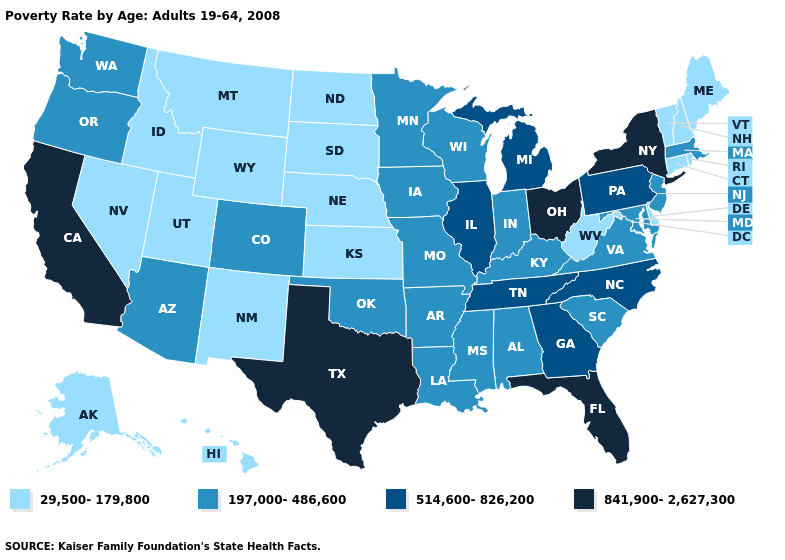Does Florida have the highest value in the South?
Short answer required. Yes. What is the value of Maine?
Give a very brief answer. 29,500-179,800. Does the first symbol in the legend represent the smallest category?
Give a very brief answer. Yes. Name the states that have a value in the range 29,500-179,800?
Keep it brief. Alaska, Connecticut, Delaware, Hawaii, Idaho, Kansas, Maine, Montana, Nebraska, Nevada, New Hampshire, New Mexico, North Dakota, Rhode Island, South Dakota, Utah, Vermont, West Virginia, Wyoming. Name the states that have a value in the range 197,000-486,600?
Give a very brief answer. Alabama, Arizona, Arkansas, Colorado, Indiana, Iowa, Kentucky, Louisiana, Maryland, Massachusetts, Minnesota, Mississippi, Missouri, New Jersey, Oklahoma, Oregon, South Carolina, Virginia, Washington, Wisconsin. What is the value of Alaska?
Short answer required. 29,500-179,800. Among the states that border Kansas , does Oklahoma have the highest value?
Write a very short answer. Yes. Does the first symbol in the legend represent the smallest category?
Keep it brief. Yes. What is the value of Delaware?
Quick response, please. 29,500-179,800. Which states have the lowest value in the USA?
Short answer required. Alaska, Connecticut, Delaware, Hawaii, Idaho, Kansas, Maine, Montana, Nebraska, Nevada, New Hampshire, New Mexico, North Dakota, Rhode Island, South Dakota, Utah, Vermont, West Virginia, Wyoming. Name the states that have a value in the range 29,500-179,800?
Be succinct. Alaska, Connecticut, Delaware, Hawaii, Idaho, Kansas, Maine, Montana, Nebraska, Nevada, New Hampshire, New Mexico, North Dakota, Rhode Island, South Dakota, Utah, Vermont, West Virginia, Wyoming. Name the states that have a value in the range 29,500-179,800?
Answer briefly. Alaska, Connecticut, Delaware, Hawaii, Idaho, Kansas, Maine, Montana, Nebraska, Nevada, New Hampshire, New Mexico, North Dakota, Rhode Island, South Dakota, Utah, Vermont, West Virginia, Wyoming. What is the lowest value in states that border Montana?
Answer briefly. 29,500-179,800. What is the highest value in the South ?
Give a very brief answer. 841,900-2,627,300. Name the states that have a value in the range 514,600-826,200?
Short answer required. Georgia, Illinois, Michigan, North Carolina, Pennsylvania, Tennessee. 